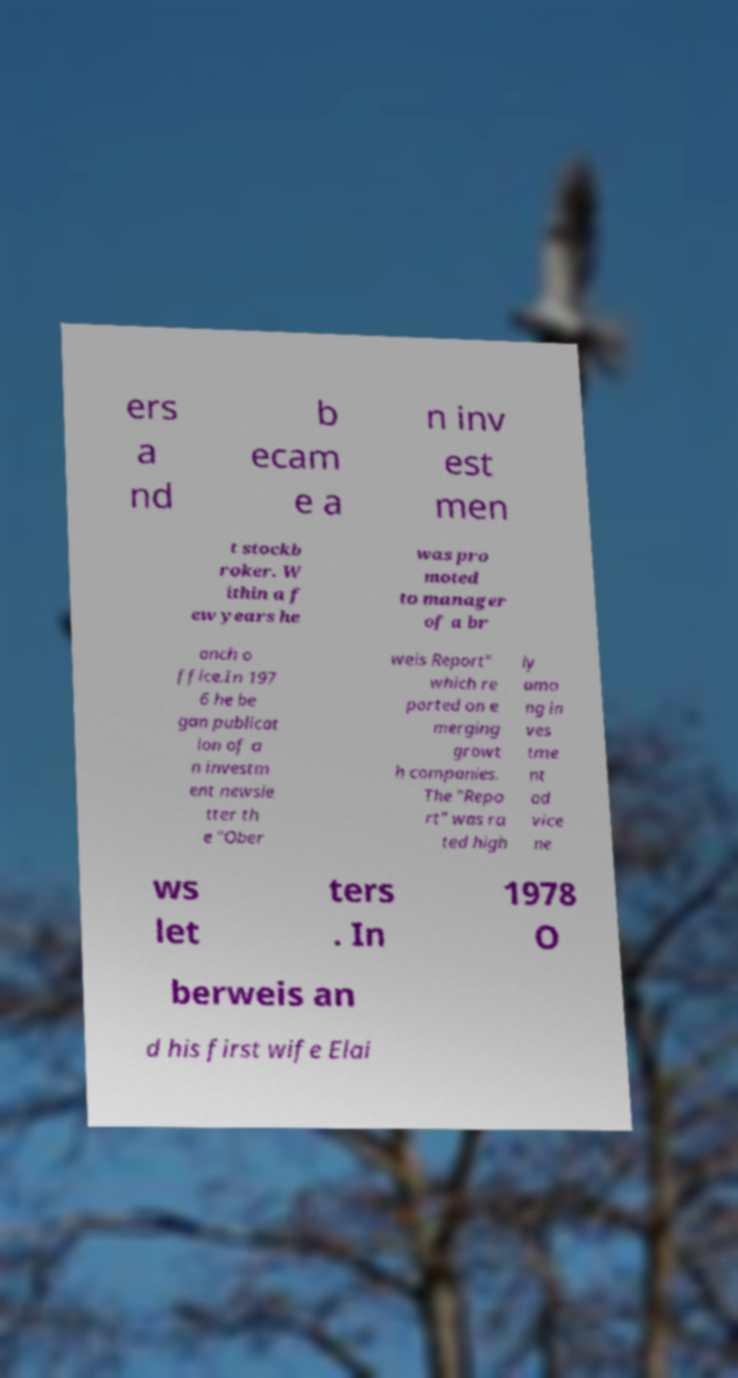Can you read and provide the text displayed in the image?This photo seems to have some interesting text. Can you extract and type it out for me? ers a nd b ecam e a n inv est men t stockb roker. W ithin a f ew years he was pro moted to manager of a br anch o ffice.In 197 6 he be gan publicat ion of a n investm ent newsle tter th e "Ober weis Report" which re ported on e merging growt h companies. The "Repo rt" was ra ted high ly amo ng in ves tme nt ad vice ne ws let ters . In 1978 O berweis an d his first wife Elai 